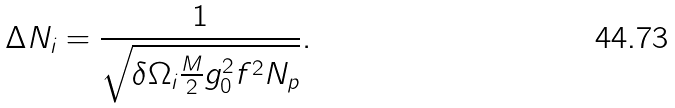Convert formula to latex. <formula><loc_0><loc_0><loc_500><loc_500>\Delta N _ { i } = \frac { 1 } { \sqrt { \delta \Omega _ { i } \frac { M } { 2 } g _ { 0 } ^ { 2 } f ^ { 2 } N _ { p } } } .</formula> 